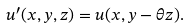<formula> <loc_0><loc_0><loc_500><loc_500>u ^ { \prime } ( x , y , z ) = u ( x , y - \theta z ) .</formula> 